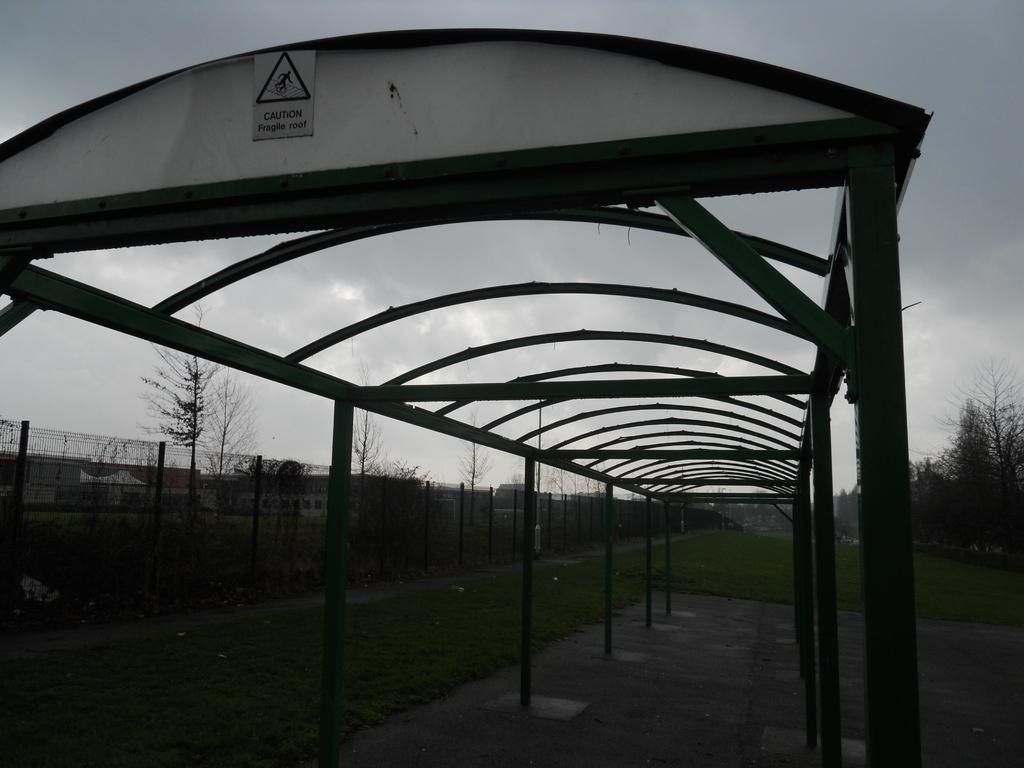How would you summarize this image in a sentence or two? In this image we can see a shed with some text written on it and we can also see trees, grass, fencing and sky. 